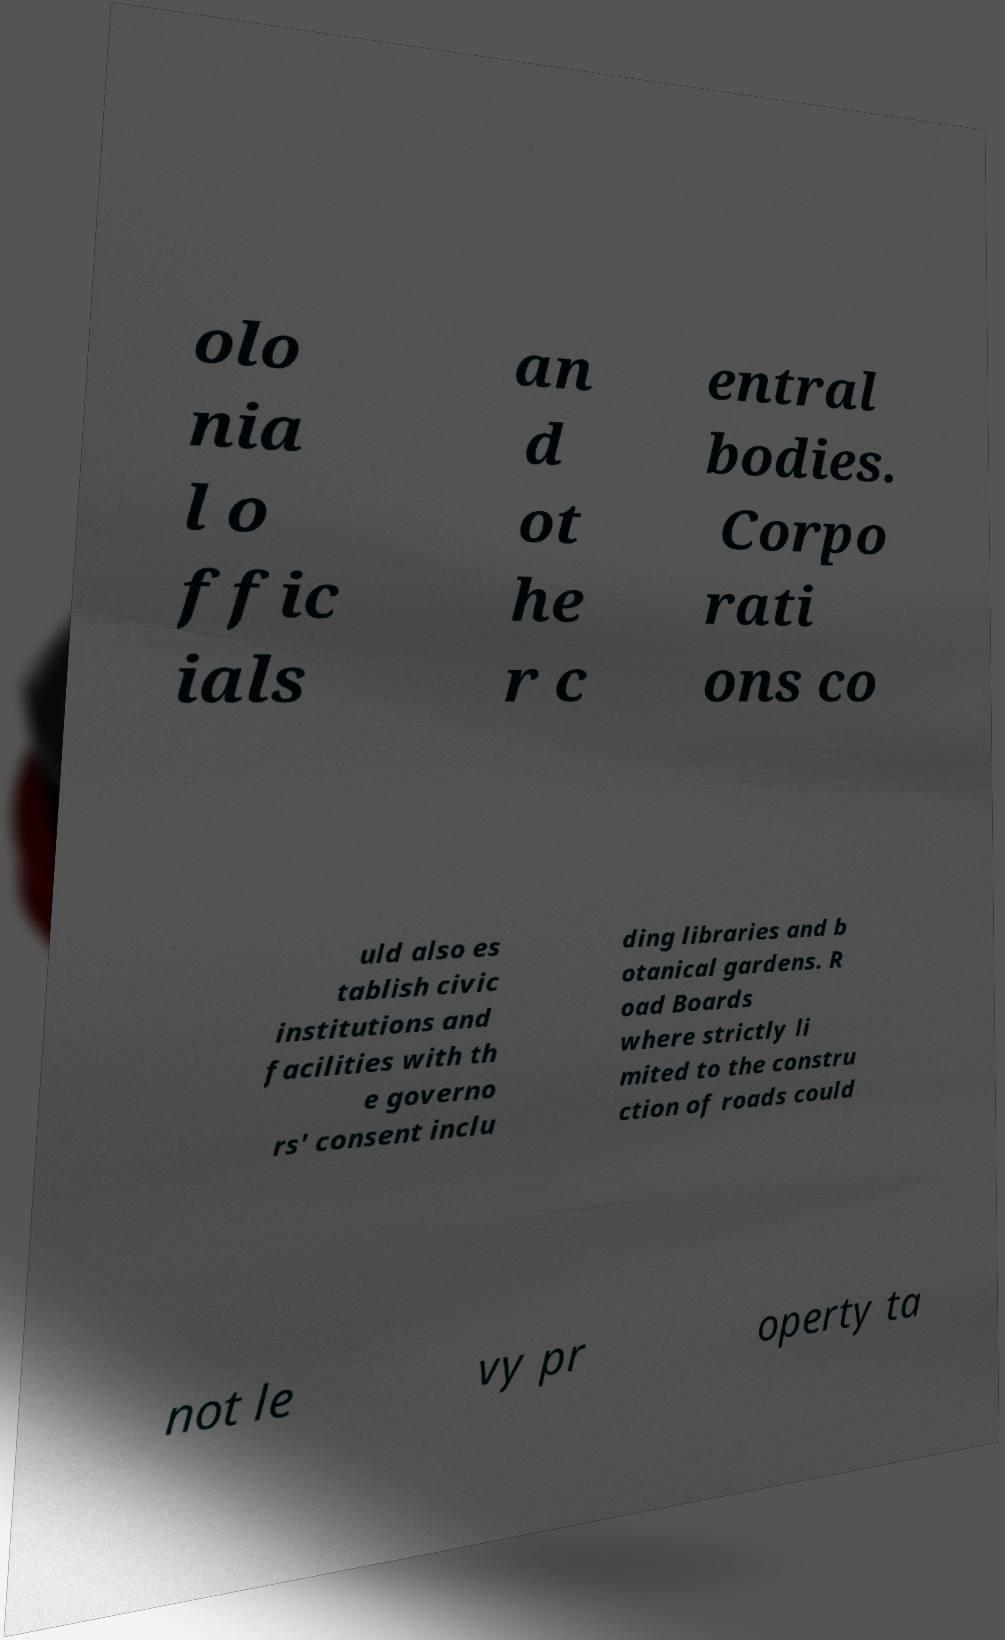Can you read and provide the text displayed in the image?This photo seems to have some interesting text. Can you extract and type it out for me? olo nia l o ffic ials an d ot he r c entral bodies. Corpo rati ons co uld also es tablish civic institutions and facilities with th e governo rs' consent inclu ding libraries and b otanical gardens. R oad Boards where strictly li mited to the constru ction of roads could not le vy pr operty ta 